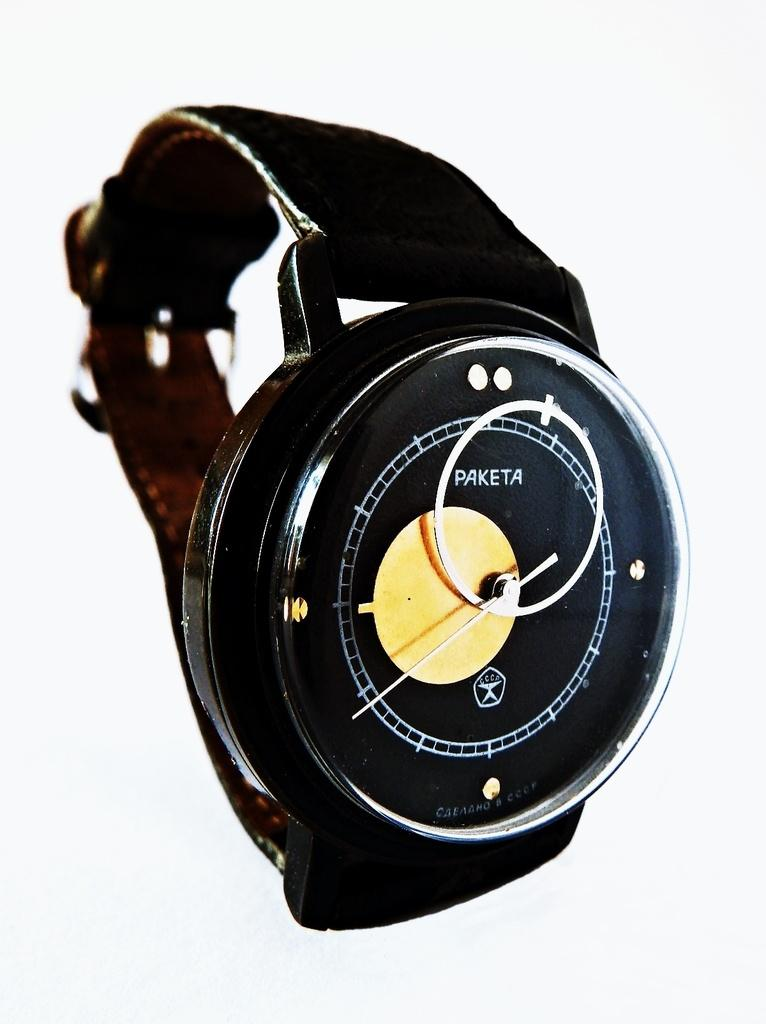Provide a one-sentence caption for the provided image. The Paketa watch has only a single hand. 